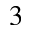Convert formula to latex. <formula><loc_0><loc_0><loc_500><loc_500>^ { 3 }</formula> 